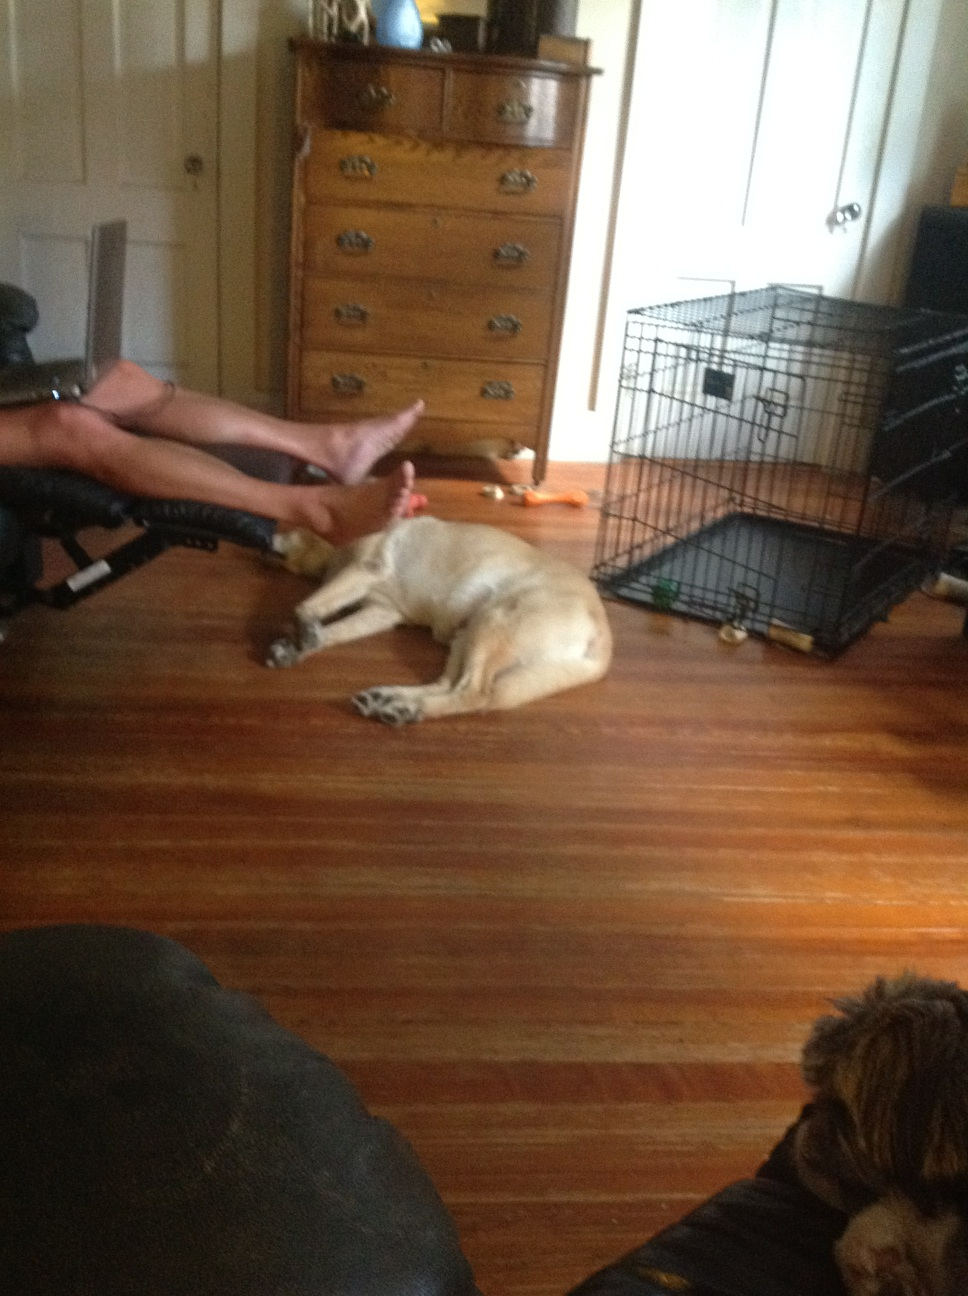What is on the floor? from Vizwiz dog 